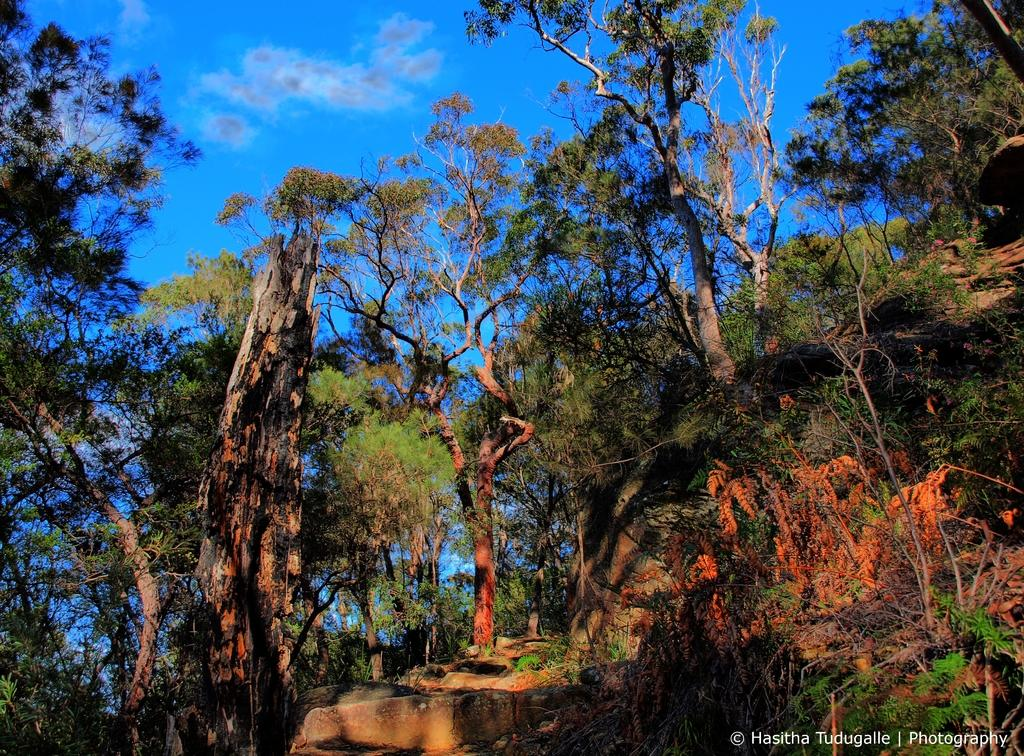What type of natural elements can be seen in the image? There are trees and rocks in the image. Can you describe the text or image in the right bottom corner of the image? Unfortunately, the specific content of the text or image in the right bottom corner cannot be determined from the provided facts. How many different types of natural elements are present in the image? There are two different types of natural elements present in the image: trees and rocks. What type of boat is sailing peacefully in the image? There is no boat present in the image; it only features trees and rocks. What message of peace can be found in the image? There is no message of peace or any text or image related to peace in the image. 